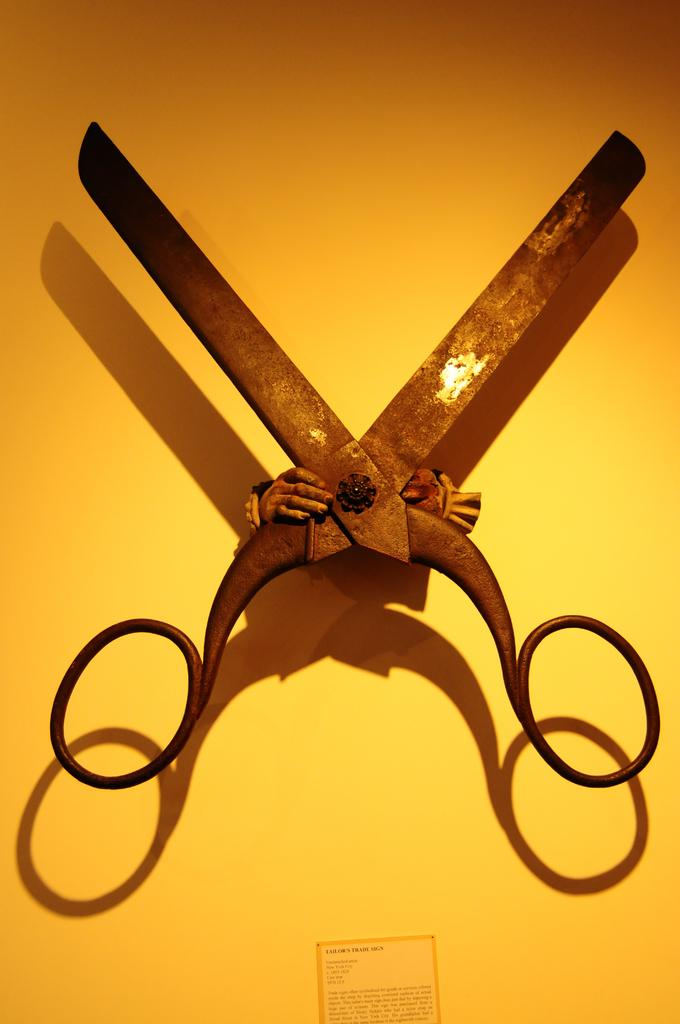What is the main object in the picture? There is a scissor in the picture. Where is the scissor located? The scissor is attached to a yellow color wall. Are there any other objects attached to the wall in the picture? Yes, there are other objects attached to the wall in the picture. What type of coach can be seen in the picture? There is no coach present in the picture; it features a scissor attached to a yellow color wall and other objects on the wall. Is there a cord visible in the picture? There is no mention of a cord in the provided facts, so we cannot determine if a cord is present in the image. 